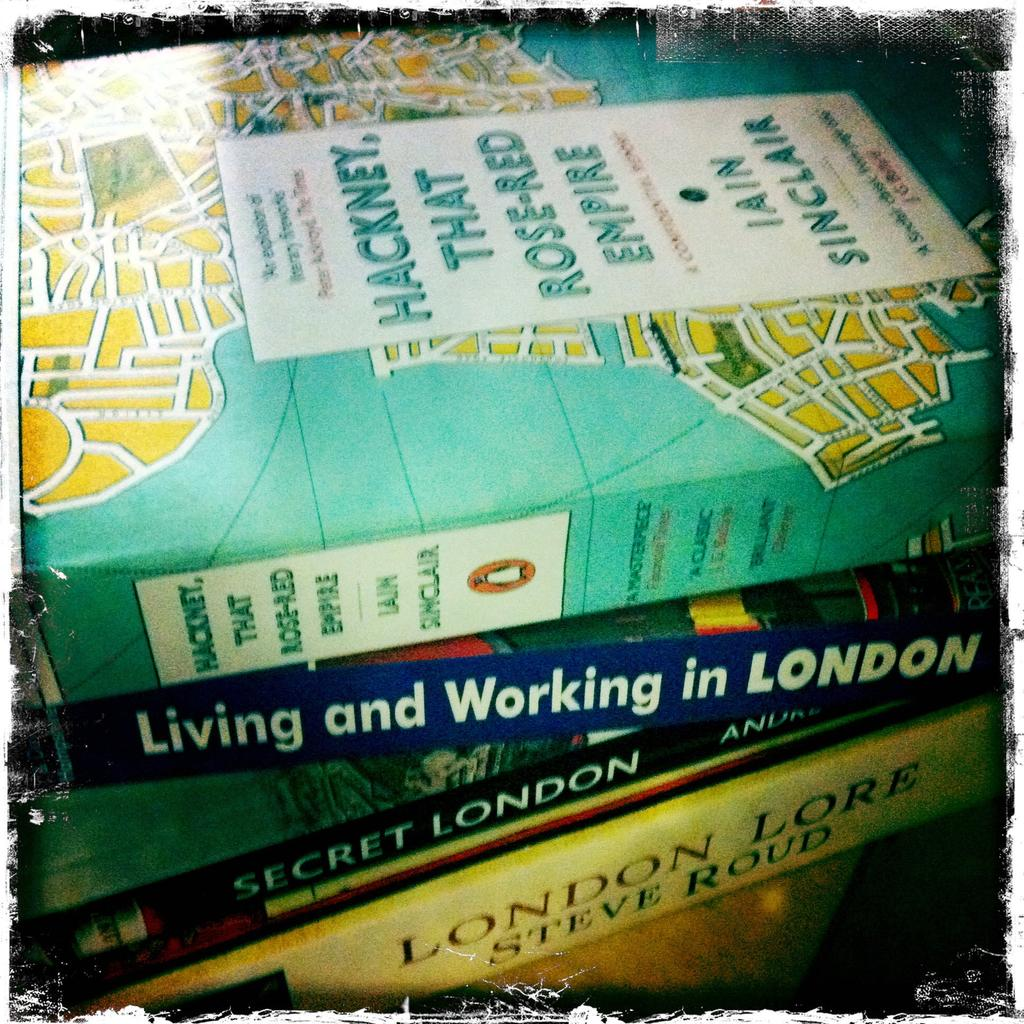<image>
Render a clear and concise summary of the photo. Four books stacked whose content is about London 